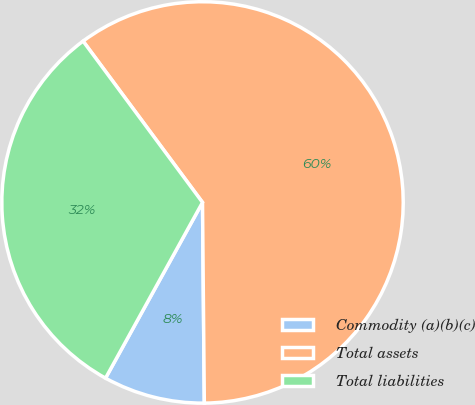<chart> <loc_0><loc_0><loc_500><loc_500><pie_chart><fcel>Commodity (a)(b)(c)<fcel>Total assets<fcel>Total liabilities<nl><fcel>8.17%<fcel>60.0%<fcel>31.83%<nl></chart> 